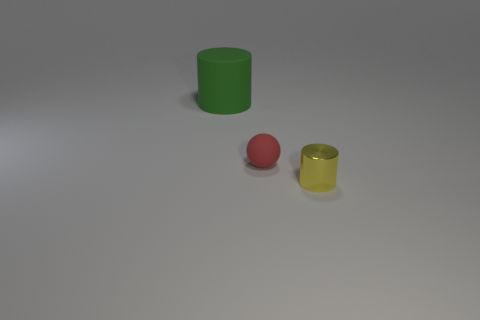Is there anything else that is the same material as the small yellow object?
Offer a terse response. No. There is a small object to the left of the tiny yellow shiny object; does it have the same shape as the thing that is behind the red thing?
Ensure brevity in your answer.  No. Are there any other cylinders made of the same material as the green cylinder?
Ensure brevity in your answer.  No. Do the tiny thing behind the tiny yellow cylinder and the yellow object have the same material?
Offer a very short reply. No. Are there more red objects on the left side of the big green cylinder than red objects right of the red object?
Give a very brief answer. No. There is a cylinder that is the same size as the red matte sphere; what is its color?
Offer a very short reply. Yellow. Is there a big block of the same color as the small metal thing?
Your response must be concise. No. Does the cylinder that is to the left of the tiny yellow cylinder have the same color as the small object behind the tiny yellow metal cylinder?
Your response must be concise. No. There is a thing behind the small rubber ball; what material is it?
Your answer should be compact. Rubber. There is a cylinder that is made of the same material as the red object; what color is it?
Offer a very short reply. Green. 